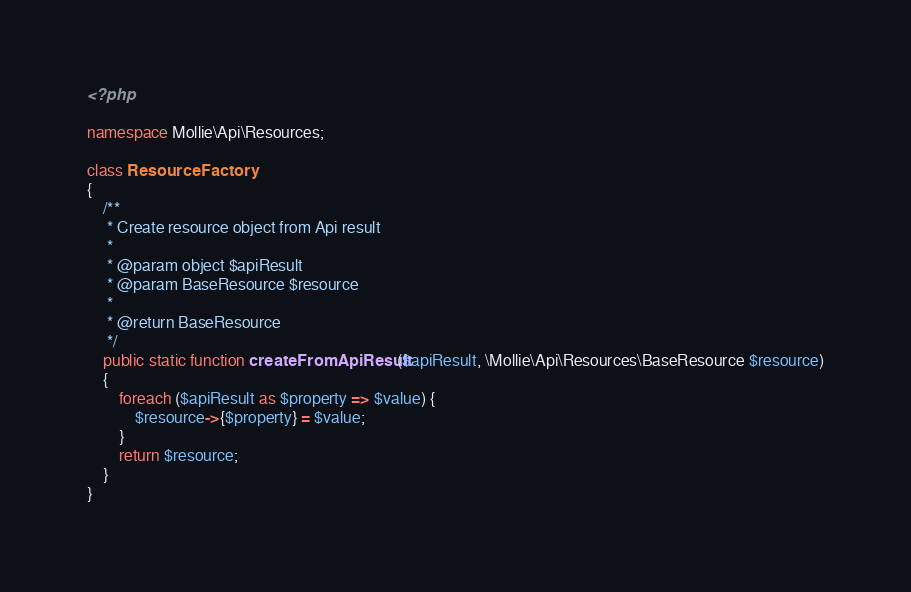<code> <loc_0><loc_0><loc_500><loc_500><_PHP_><?php

namespace Mollie\Api\Resources;

class ResourceFactory
{
    /**
     * Create resource object from Api result
     *
     * @param object $apiResult
     * @param BaseResource $resource
     *
     * @return BaseResource
     */
    public static function createFromApiResult($apiResult, \Mollie\Api\Resources\BaseResource $resource)
    {
        foreach ($apiResult as $property => $value) {
            $resource->{$property} = $value;
        }
        return $resource;
    }
}
</code> 